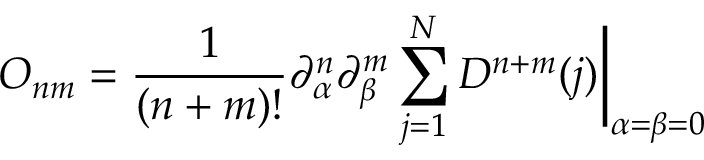Convert formula to latex. <formula><loc_0><loc_0><loc_500><loc_500>O _ { n m } = { \frac { 1 } { ( n + m ) ! } } \partial _ { \alpha } ^ { n } \partial _ { \beta } ^ { m } \sum _ { j = 1 } ^ { N } D ^ { n + m } ( j ) \Big | _ { \alpha = \beta = 0 }</formula> 